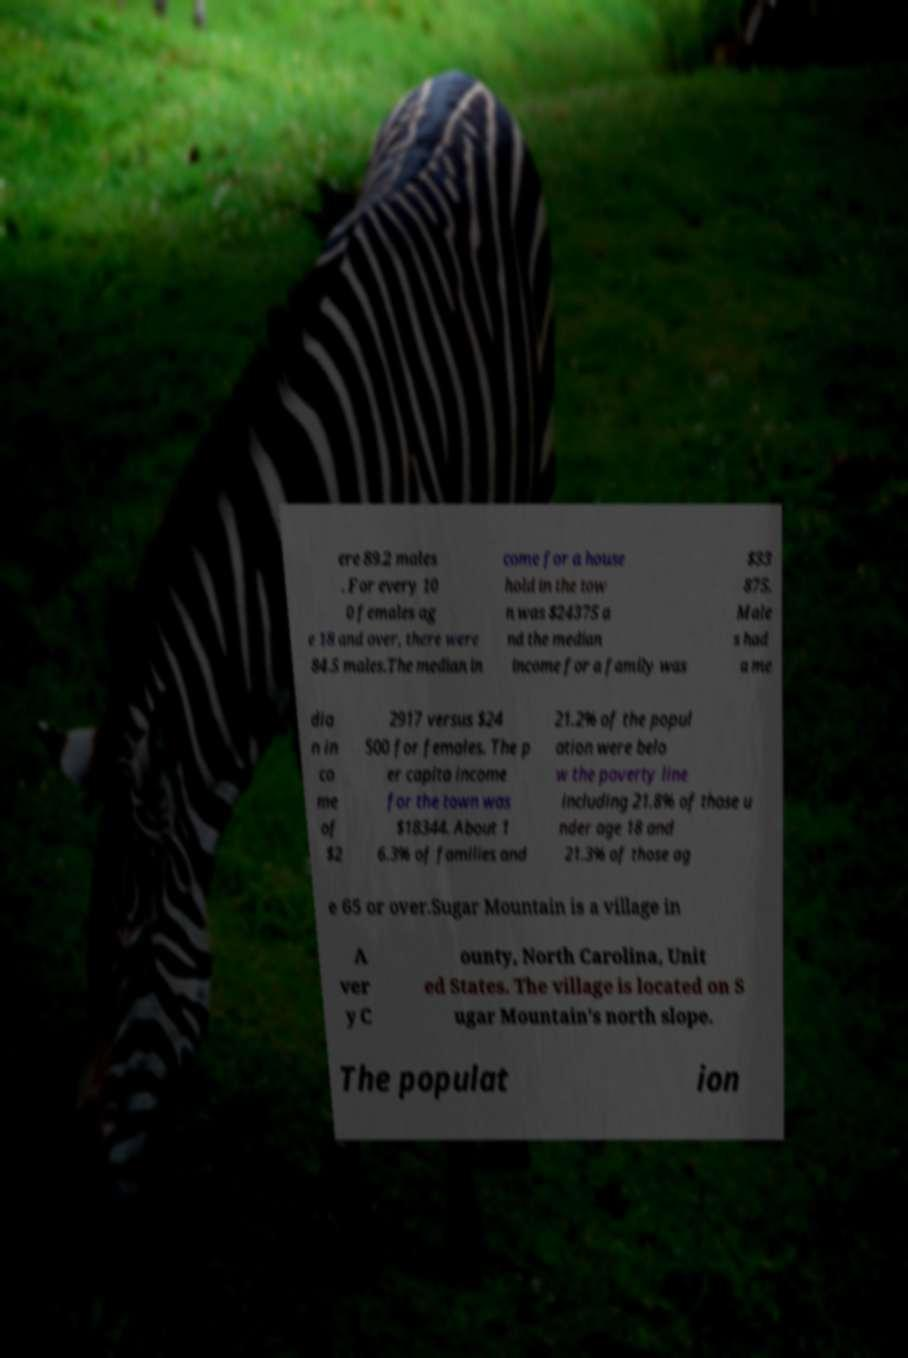There's text embedded in this image that I need extracted. Can you transcribe it verbatim? ere 89.2 males . For every 10 0 females ag e 18 and over, there were 84.5 males.The median in come for a house hold in the tow n was $24375 a nd the median income for a family was $33 875. Male s had a me dia n in co me of $2 2917 versus $24 500 for females. The p er capita income for the town was $18344. About 1 6.3% of families and 21.2% of the popul ation were belo w the poverty line including 21.8% of those u nder age 18 and 21.3% of those ag e 65 or over.Sugar Mountain is a village in A ver y C ounty, North Carolina, Unit ed States. The village is located on S ugar Mountain's north slope. The populat ion 